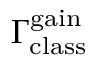Convert formula to latex. <formula><loc_0><loc_0><loc_500><loc_500>\Gamma _ { c l a s s } ^ { g a i n }</formula> 